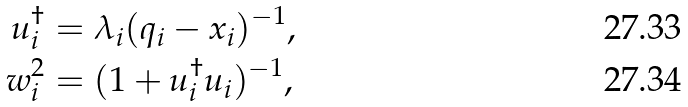<formula> <loc_0><loc_0><loc_500><loc_500>u _ { i } ^ { \dagger } & = \lambda _ { i } ( q _ { i } - x _ { i } ) ^ { - 1 } , \\ w _ { i } ^ { 2 } & = ( 1 + u _ { i } ^ { \dagger } u _ { i } ) ^ { - 1 } ,</formula> 